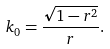<formula> <loc_0><loc_0><loc_500><loc_500>k _ { 0 } = \frac { \sqrt { 1 - r ^ { 2 } } } { r } .</formula> 